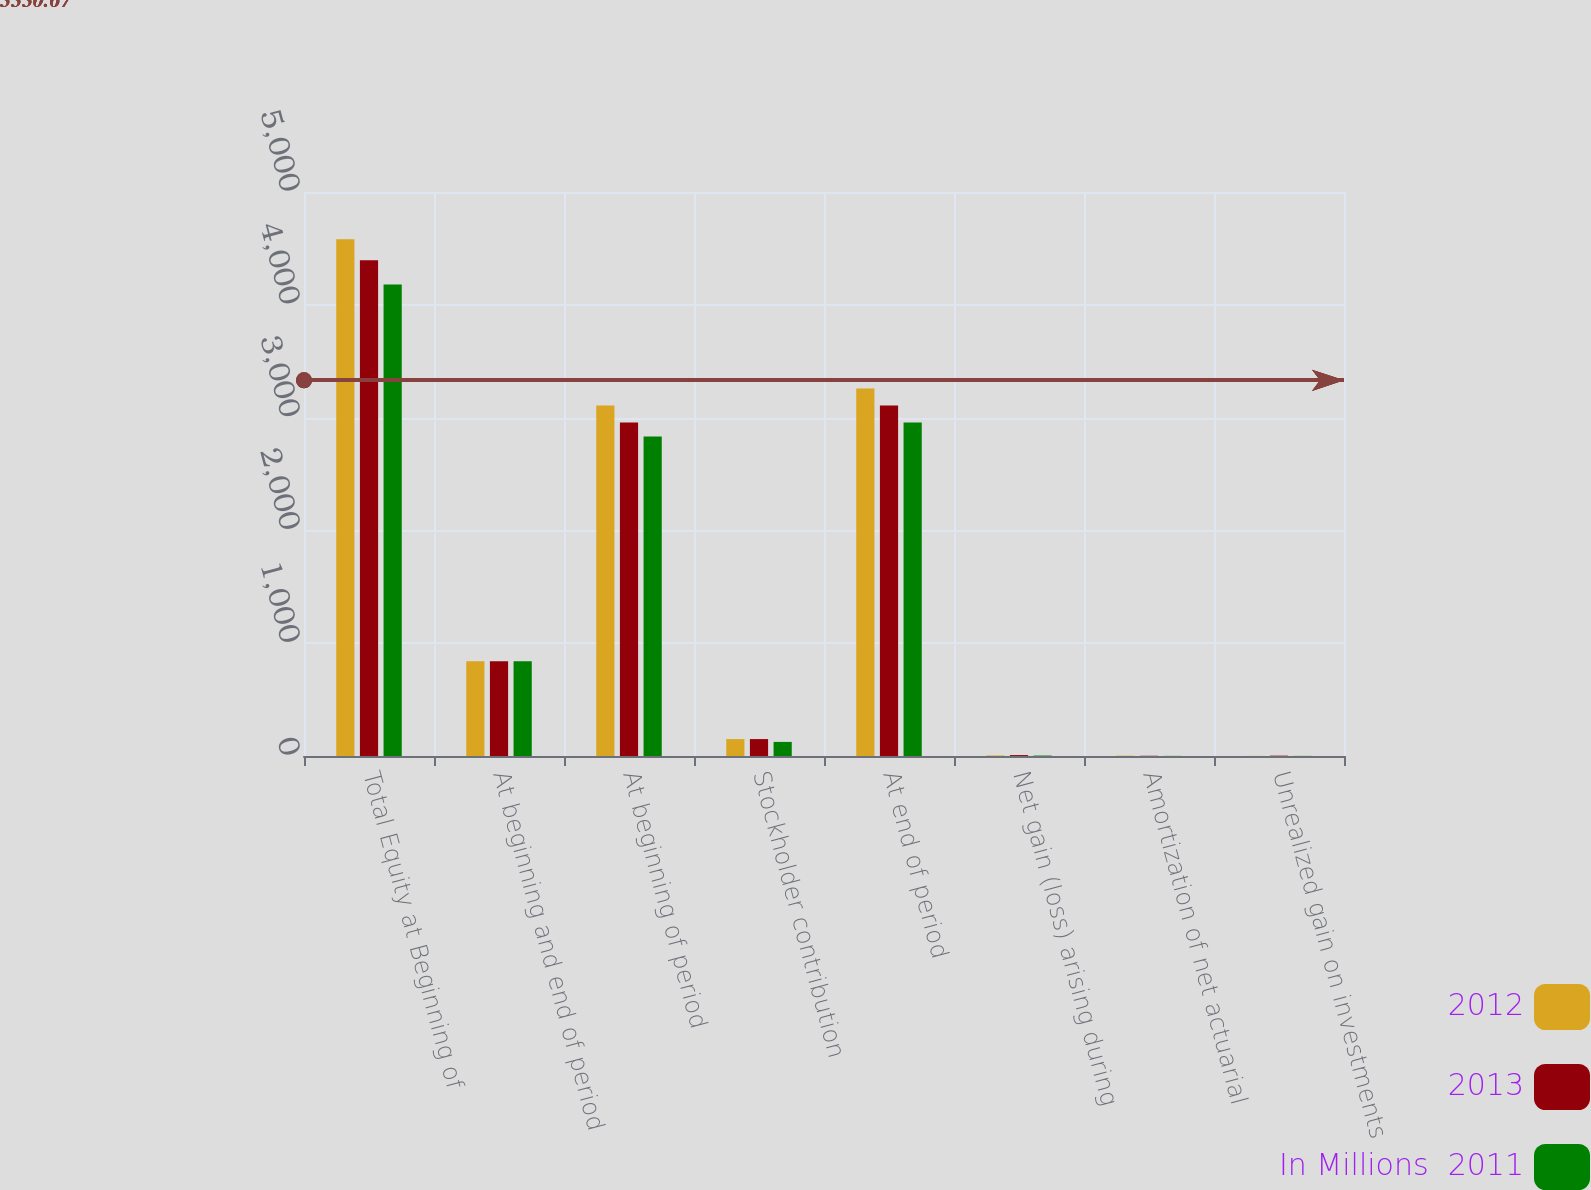Convert chart. <chart><loc_0><loc_0><loc_500><loc_500><stacked_bar_chart><ecel><fcel>Total Equity at Beginning of<fcel>At beginning and end of period<fcel>At beginning of period<fcel>Stockholder contribution<fcel>At end of period<fcel>Net gain (loss) arising during<fcel>Amortization of net actuarial<fcel>Unrealized gain on investments<nl><fcel>2012<fcel>4582<fcel>841<fcel>3107<fcel>150<fcel>3257<fcel>5<fcel>3<fcel>1<nl><fcel>2013<fcel>4394<fcel>841<fcel>2957<fcel>150<fcel>3107<fcel>8<fcel>2<fcel>3<nl><fcel>In Millions  2011<fcel>4180<fcel>841<fcel>2832<fcel>125<fcel>2957<fcel>4<fcel>1<fcel>1<nl></chart> 